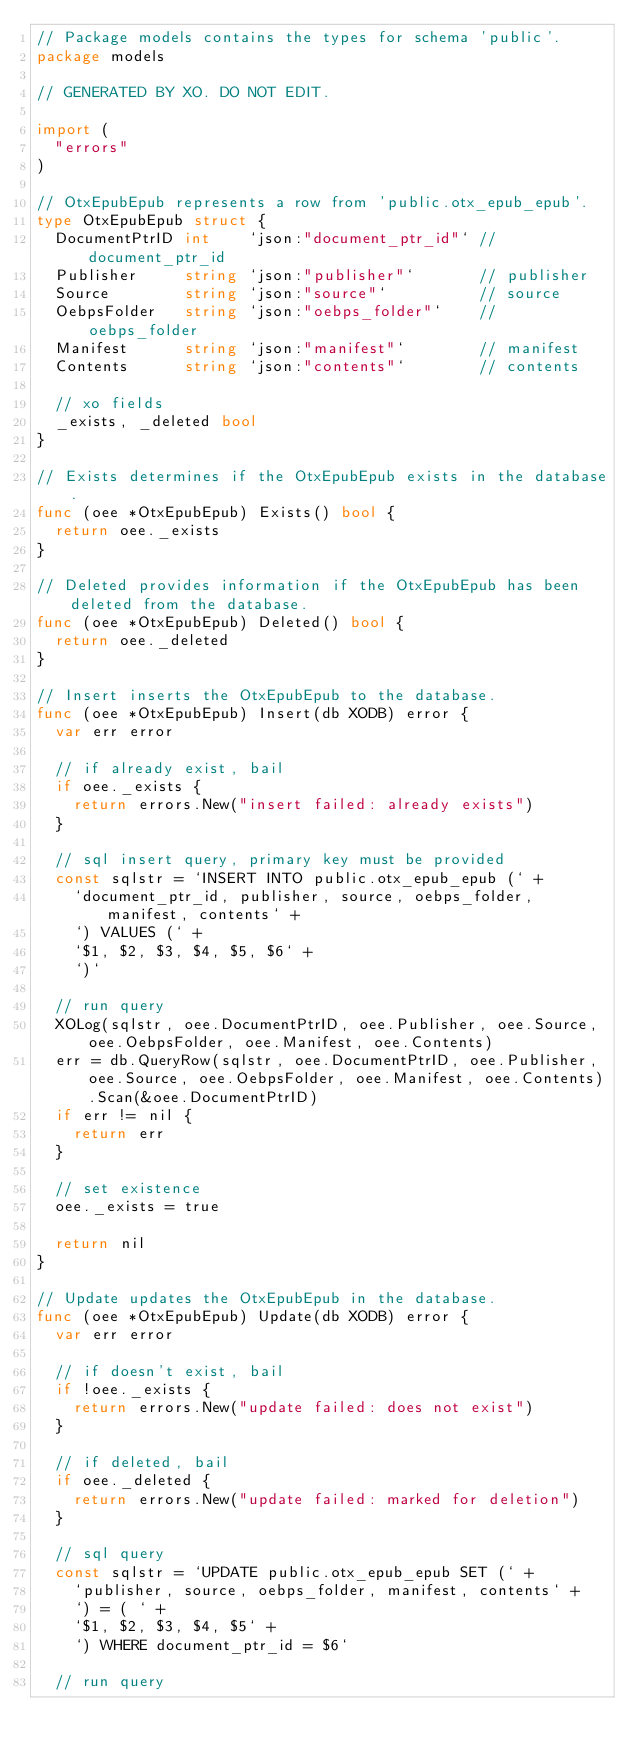Convert code to text. <code><loc_0><loc_0><loc_500><loc_500><_Go_>// Package models contains the types for schema 'public'.
package models

// GENERATED BY XO. DO NOT EDIT.

import (
	"errors"
)

// OtxEpubEpub represents a row from 'public.otx_epub_epub'.
type OtxEpubEpub struct {
	DocumentPtrID int    `json:"document_ptr_id"` // document_ptr_id
	Publisher     string `json:"publisher"`       // publisher
	Source        string `json:"source"`          // source
	OebpsFolder   string `json:"oebps_folder"`    // oebps_folder
	Manifest      string `json:"manifest"`        // manifest
	Contents      string `json:"contents"`        // contents

	// xo fields
	_exists, _deleted bool
}

// Exists determines if the OtxEpubEpub exists in the database.
func (oee *OtxEpubEpub) Exists() bool {
	return oee._exists
}

// Deleted provides information if the OtxEpubEpub has been deleted from the database.
func (oee *OtxEpubEpub) Deleted() bool {
	return oee._deleted
}

// Insert inserts the OtxEpubEpub to the database.
func (oee *OtxEpubEpub) Insert(db XODB) error {
	var err error

	// if already exist, bail
	if oee._exists {
		return errors.New("insert failed: already exists")
	}

	// sql insert query, primary key must be provided
	const sqlstr = `INSERT INTO public.otx_epub_epub (` +
		`document_ptr_id, publisher, source, oebps_folder, manifest, contents` +
		`) VALUES (` +
		`$1, $2, $3, $4, $5, $6` +
		`)`

	// run query
	XOLog(sqlstr, oee.DocumentPtrID, oee.Publisher, oee.Source, oee.OebpsFolder, oee.Manifest, oee.Contents)
	err = db.QueryRow(sqlstr, oee.DocumentPtrID, oee.Publisher, oee.Source, oee.OebpsFolder, oee.Manifest, oee.Contents).Scan(&oee.DocumentPtrID)
	if err != nil {
		return err
	}

	// set existence
	oee._exists = true

	return nil
}

// Update updates the OtxEpubEpub in the database.
func (oee *OtxEpubEpub) Update(db XODB) error {
	var err error

	// if doesn't exist, bail
	if !oee._exists {
		return errors.New("update failed: does not exist")
	}

	// if deleted, bail
	if oee._deleted {
		return errors.New("update failed: marked for deletion")
	}

	// sql query
	const sqlstr = `UPDATE public.otx_epub_epub SET (` +
		`publisher, source, oebps_folder, manifest, contents` +
		`) = ( ` +
		`$1, $2, $3, $4, $5` +
		`) WHERE document_ptr_id = $6`

	// run query</code> 